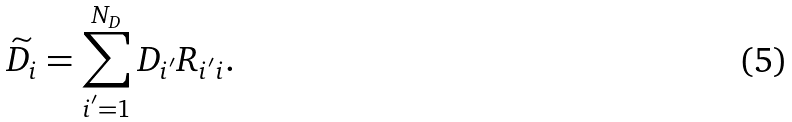<formula> <loc_0><loc_0><loc_500><loc_500>\widetilde { D _ { i } } = \sum _ { i ^ { ^ { \prime } } = 1 } ^ { N _ { D } } D _ { i ^ { ^ { \prime } } } R _ { i ^ { ^ { \prime } } i } .</formula> 